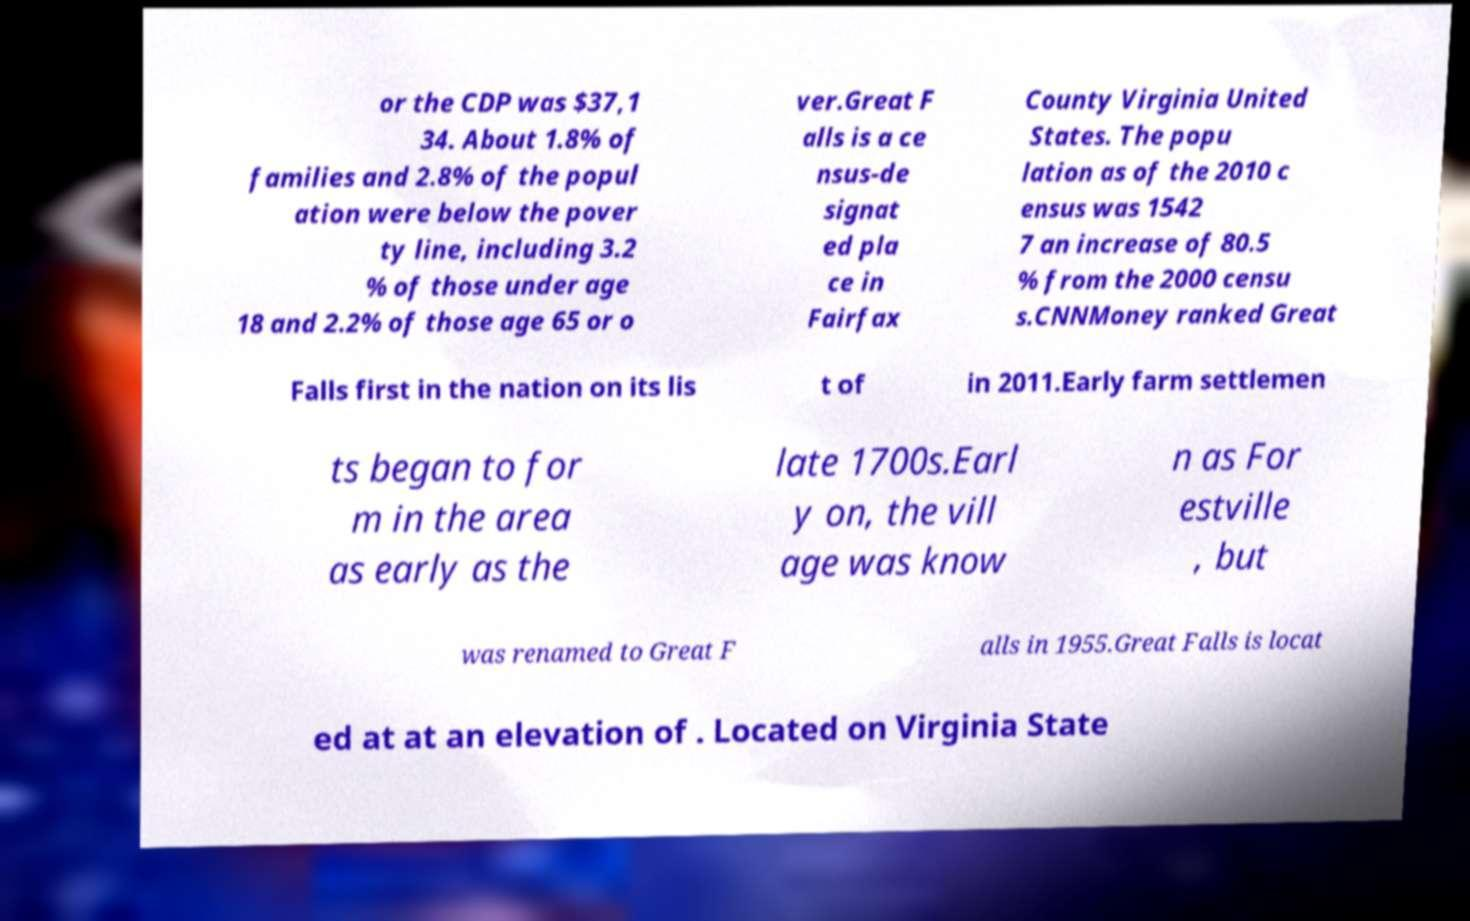There's text embedded in this image that I need extracted. Can you transcribe it verbatim? or the CDP was $37,1 34. About 1.8% of families and 2.8% of the popul ation were below the pover ty line, including 3.2 % of those under age 18 and 2.2% of those age 65 or o ver.Great F alls is a ce nsus-de signat ed pla ce in Fairfax County Virginia United States. The popu lation as of the 2010 c ensus was 1542 7 an increase of 80.5 % from the 2000 censu s.CNNMoney ranked Great Falls first in the nation on its lis t of in 2011.Early farm settlemen ts began to for m in the area as early as the late 1700s.Earl y on, the vill age was know n as For estville , but was renamed to Great F alls in 1955.Great Falls is locat ed at at an elevation of . Located on Virginia State 